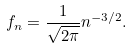Convert formula to latex. <formula><loc_0><loc_0><loc_500><loc_500>f _ { n } = \frac { 1 } { \sqrt { 2 \pi } } n ^ { - 3 / 2 } .</formula> 